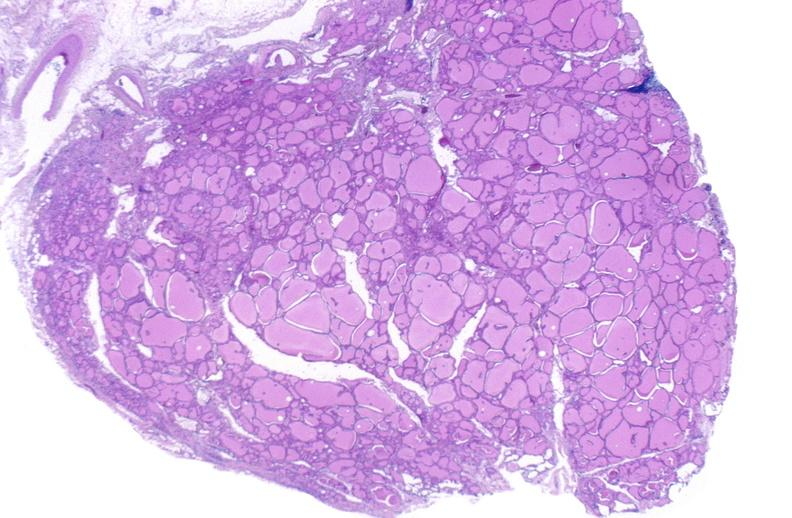does this image show thyroid gland, normal?
Answer the question using a single word or phrase. Yes 